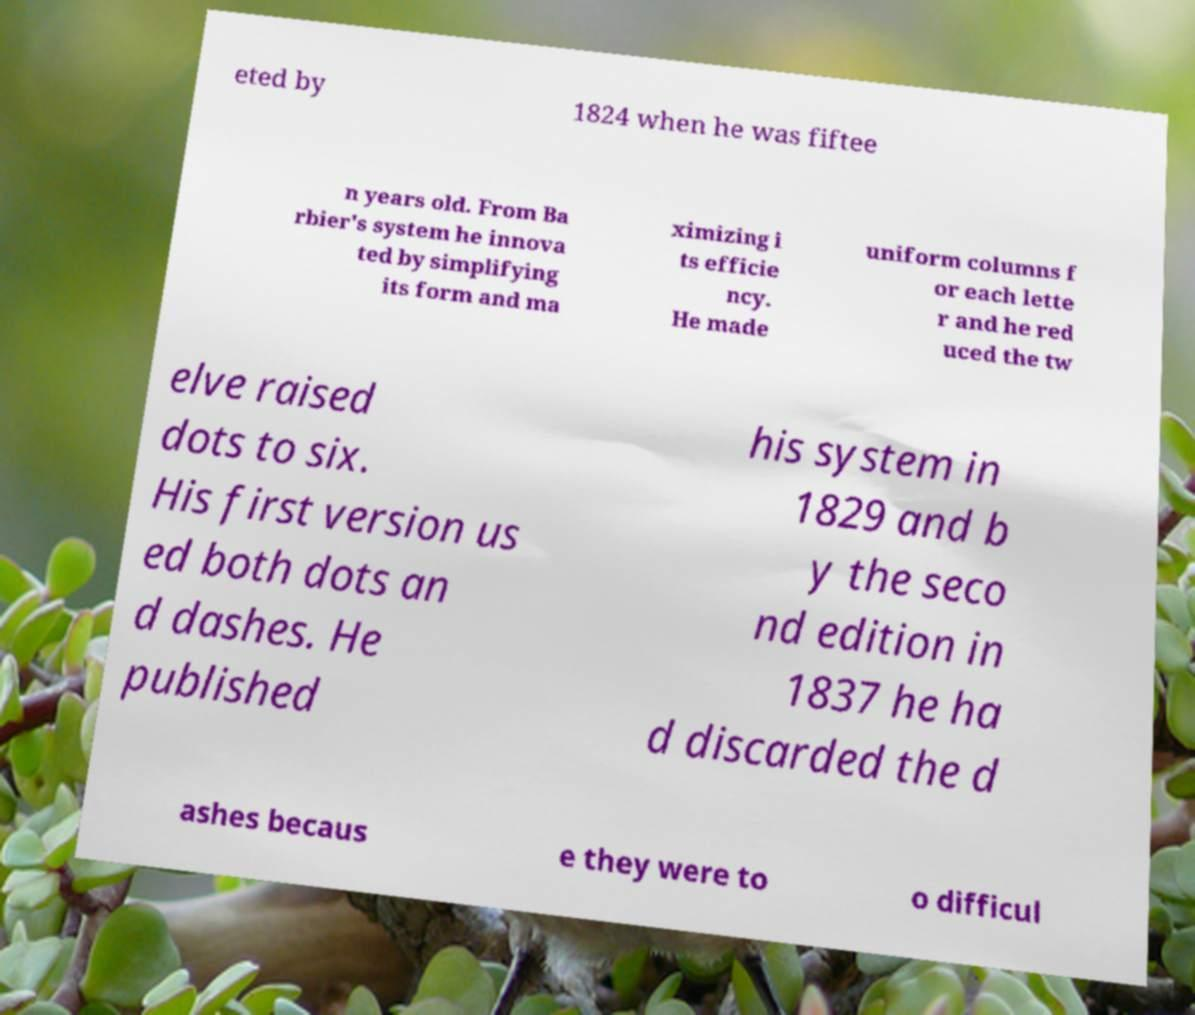Please read and relay the text visible in this image. What does it say? eted by 1824 when he was fiftee n years old. From Ba rbier's system he innova ted by simplifying its form and ma ximizing i ts efficie ncy. He made uniform columns f or each lette r and he red uced the tw elve raised dots to six. His first version us ed both dots an d dashes. He published his system in 1829 and b y the seco nd edition in 1837 he ha d discarded the d ashes becaus e they were to o difficul 